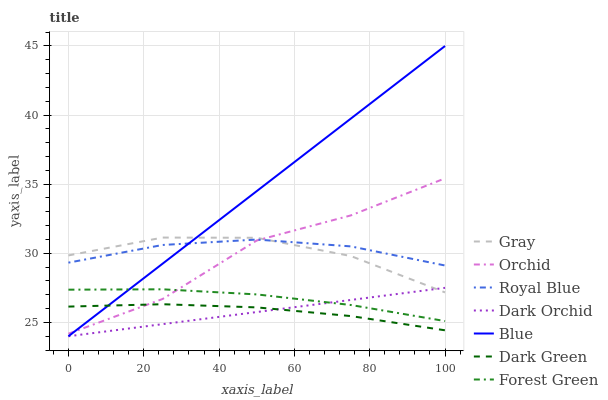Does Dark Orchid have the minimum area under the curve?
Answer yes or no. Yes. Does Blue have the maximum area under the curve?
Answer yes or no. Yes. Does Gray have the minimum area under the curve?
Answer yes or no. No. Does Gray have the maximum area under the curve?
Answer yes or no. No. Is Dark Orchid the smoothest?
Answer yes or no. Yes. Is Orchid the roughest?
Answer yes or no. Yes. Is Gray the smoothest?
Answer yes or no. No. Is Gray the roughest?
Answer yes or no. No. Does Blue have the lowest value?
Answer yes or no. Yes. Does Gray have the lowest value?
Answer yes or no. No. Does Blue have the highest value?
Answer yes or no. Yes. Does Gray have the highest value?
Answer yes or no. No. Is Forest Green less than Royal Blue?
Answer yes or no. Yes. Is Royal Blue greater than Dark Orchid?
Answer yes or no. Yes. Does Forest Green intersect Blue?
Answer yes or no. Yes. Is Forest Green less than Blue?
Answer yes or no. No. Is Forest Green greater than Blue?
Answer yes or no. No. Does Forest Green intersect Royal Blue?
Answer yes or no. No. 